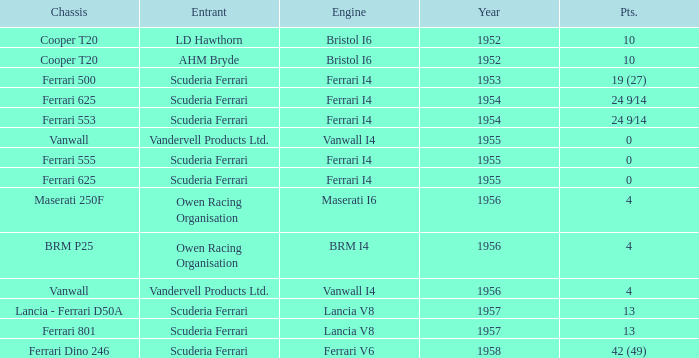Who is the entrant when the year is less than 1953? LD Hawthorn, AHM Bryde. 